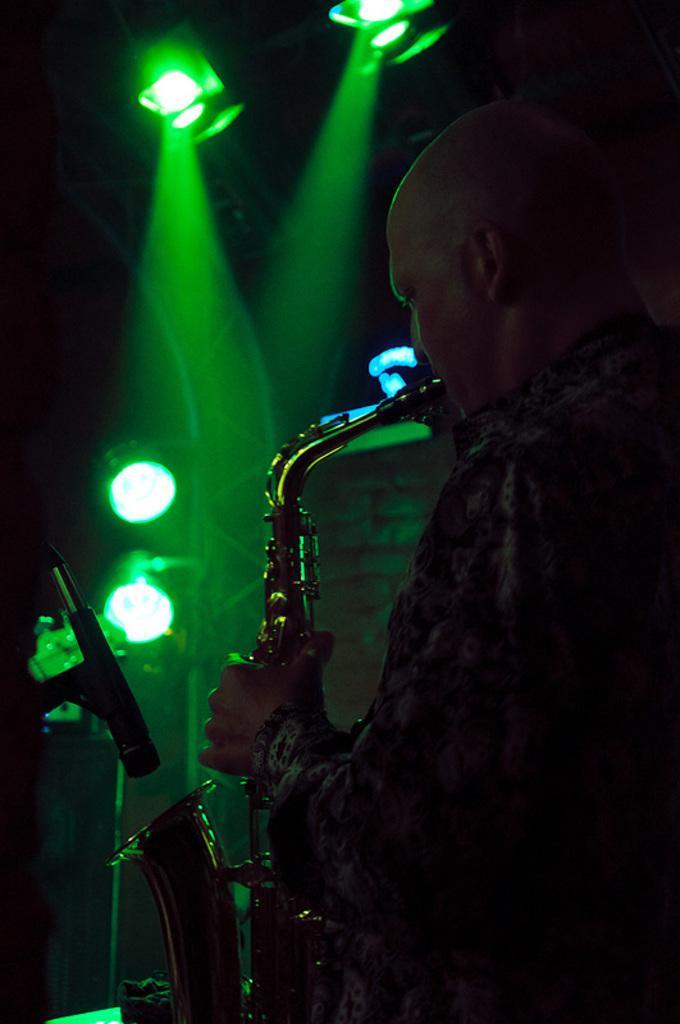Describe this image in one or two sentences. In this image we can see a person playing the saxophone. We can also see the mike. In the background there are lights. 